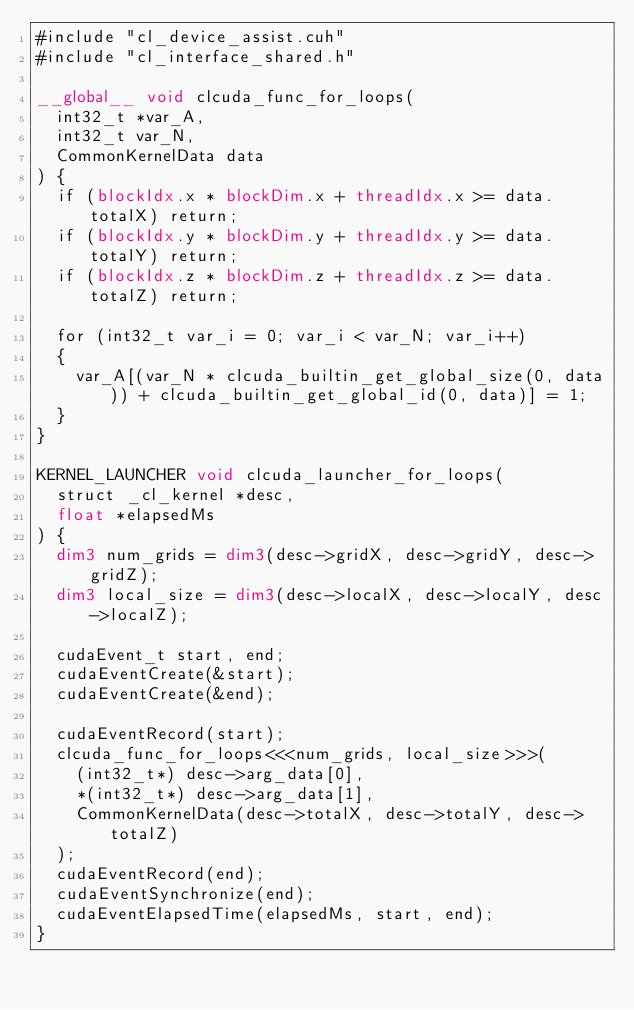<code> <loc_0><loc_0><loc_500><loc_500><_Cuda_>#include "cl_device_assist.cuh"
#include "cl_interface_shared.h"

__global__ void clcuda_func_for_loops(
	int32_t *var_A,
	int32_t var_N,
	CommonKernelData data
) {
	if (blockIdx.x * blockDim.x + threadIdx.x >= data.totalX) return;
	if (blockIdx.y * blockDim.y + threadIdx.y >= data.totalY) return;
	if (blockIdx.z * blockDim.z + threadIdx.z >= data.totalZ) return;
	
	for (int32_t var_i = 0; var_i < var_N; var_i++)
	{
		var_A[(var_N * clcuda_builtin_get_global_size(0, data)) + clcuda_builtin_get_global_id(0, data)] = 1;
	}
}

KERNEL_LAUNCHER void clcuda_launcher_for_loops(
	struct _cl_kernel *desc,
	float *elapsedMs
) {
	dim3 num_grids = dim3(desc->gridX, desc->gridY, desc->gridZ);
	dim3 local_size = dim3(desc->localX, desc->localY, desc->localZ);
	
	cudaEvent_t start, end;
	cudaEventCreate(&start);
	cudaEventCreate(&end);
	
	cudaEventRecord(start);
	clcuda_func_for_loops<<<num_grids, local_size>>>(
		(int32_t*) desc->arg_data[0],
		*(int32_t*) desc->arg_data[1],
		CommonKernelData(desc->totalX, desc->totalY, desc->totalZ)
	);
	cudaEventRecord(end);
	cudaEventSynchronize(end);
	cudaEventElapsedTime(elapsedMs, start, end);
}

</code> 